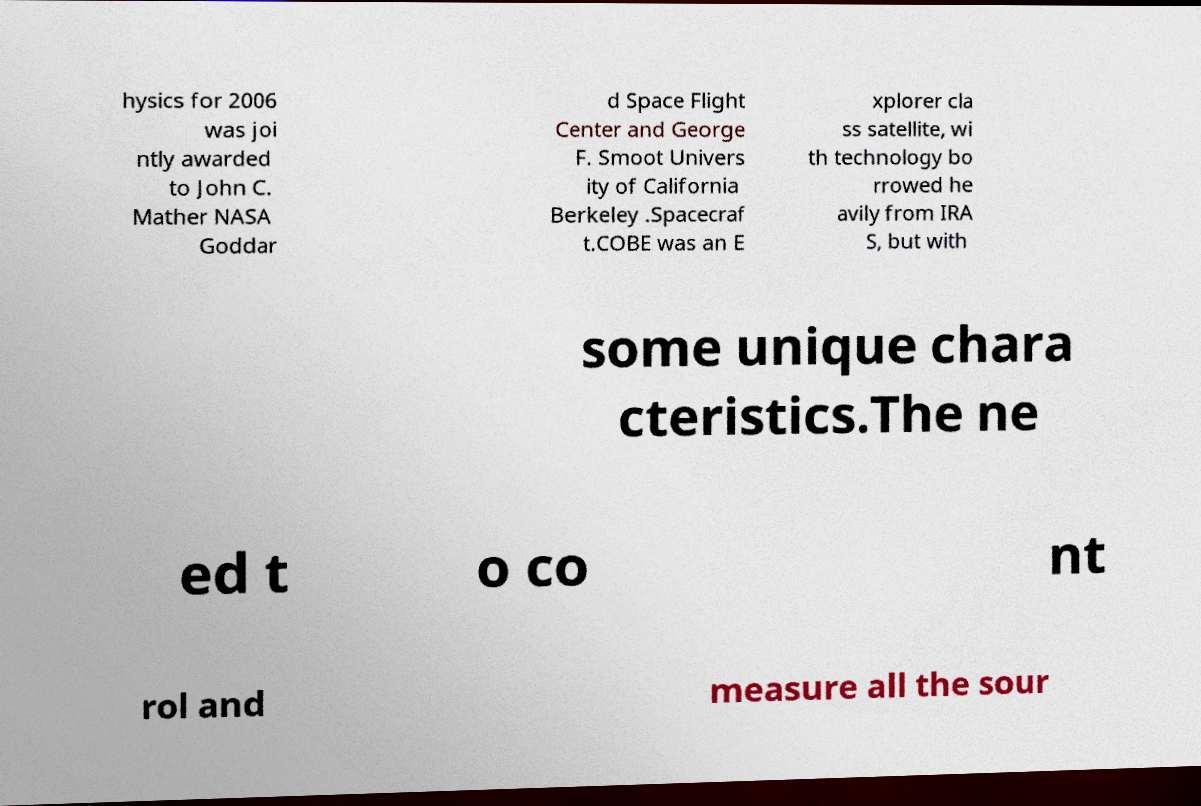Could you extract and type out the text from this image? hysics for 2006 was joi ntly awarded to John C. Mather NASA Goddar d Space Flight Center and George F. Smoot Univers ity of California Berkeley .Spacecraf t.COBE was an E xplorer cla ss satellite, wi th technology bo rrowed he avily from IRA S, but with some unique chara cteristics.The ne ed t o co nt rol and measure all the sour 